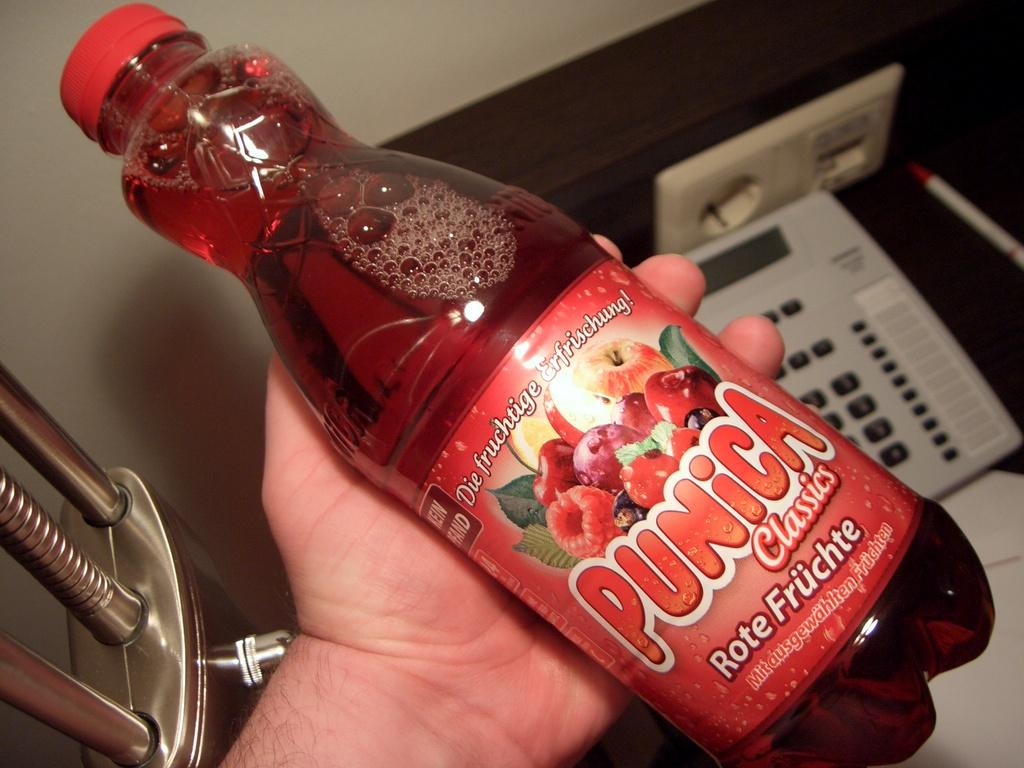<image>
Render a clear and concise summary of the photo. A hand is holding a bottle of Punica juice. 